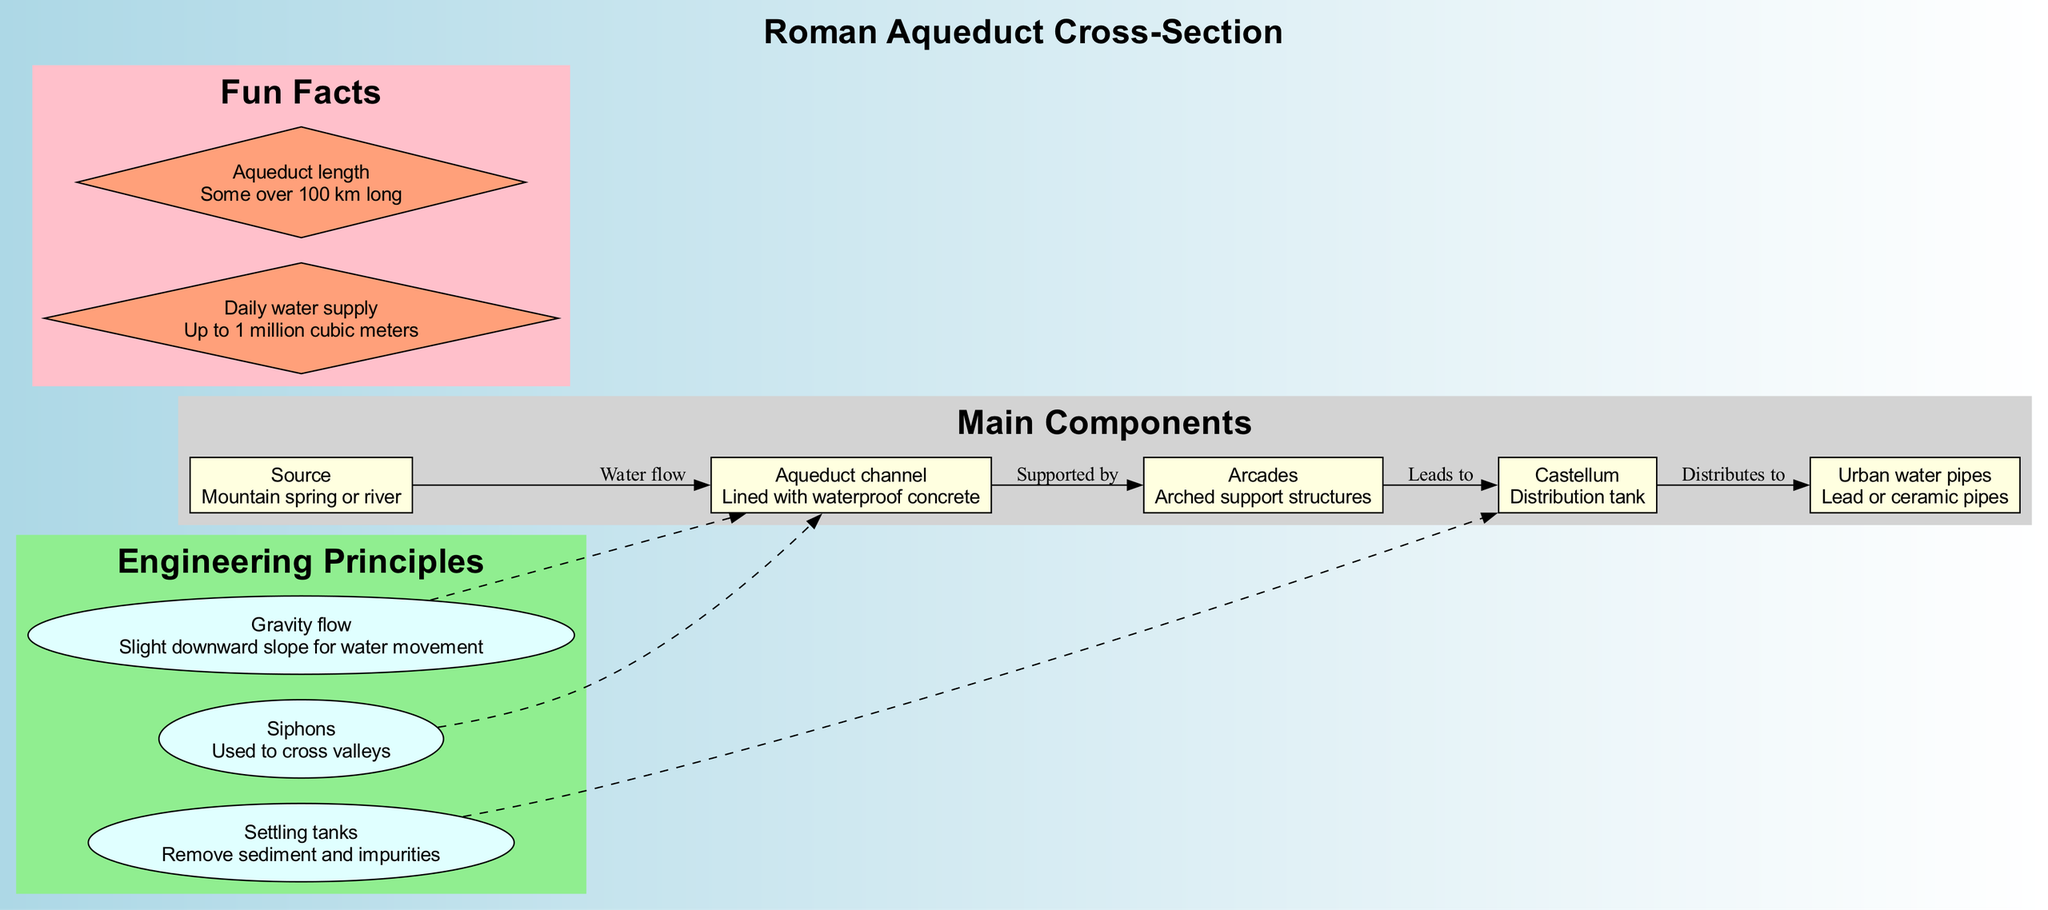What is the main source of water for the aqueduct? The diagram indicates that the water source for the aqueduct is a mountain spring or river. This is the starting point of the water flow depicted in the diagram.
Answer: Mountain spring or river How many main components are listed in the diagram? There are five main components mentioned in the diagram: Source, Aqueduct channel, Arcades, Castellum, and Urban water pipes. Counting these components gives a total of five.
Answer: 5 What structure supports the aqueduct channel? The arcades, which are arched support structures, provide support for the aqueduct channel. This relationship is shown in the diagram connecting these two components.
Answer: Arcades Which engineering principle involves the removal of impurities? The settling tanks are responsible for removing sediment and impurities from the water as depicted in the diagram, which connects to the Castellum where water is distributed.
Answer: Settling tanks What is the total daily water supply of the aqueduct? According to the fun facts in the diagram, the aqueduct can supply up to 1 million cubic meters of water each day. This was specifically noted as an interesting detail about the aqueduct system.
Answer: 1 million cubic meters How do aqueducts typically cross valleys? The diagram specifies that siphons are used for the aqueduct system to cross valleys. This is a critical engineering principle captured in the diagram that illustrates how elevation changes are managed.
Answer: Siphons What connects the Castellum to the urban water pipes? The diagram shows that the Castellum leads to urban water pipes, indicating that this is the distribution mechanism used to supply water to urban areas from the storage tank.
Answer: Distributes to What construction material is used in the aqueduct channel? The aqueduct channel is lined with waterproof concrete, as stated in the description of that component in the diagram. This helps prevent leakage and ensures the flow of water is maintained effectively.
Answer: Waterproof concrete How long can some aqueducts be? The fun facts section in the diagram reveals that some aqueducts extend over 100 kilometers in length, showcasing the ambitious engineering of the Roman aqueduct system.
Answer: Over 100 km long 